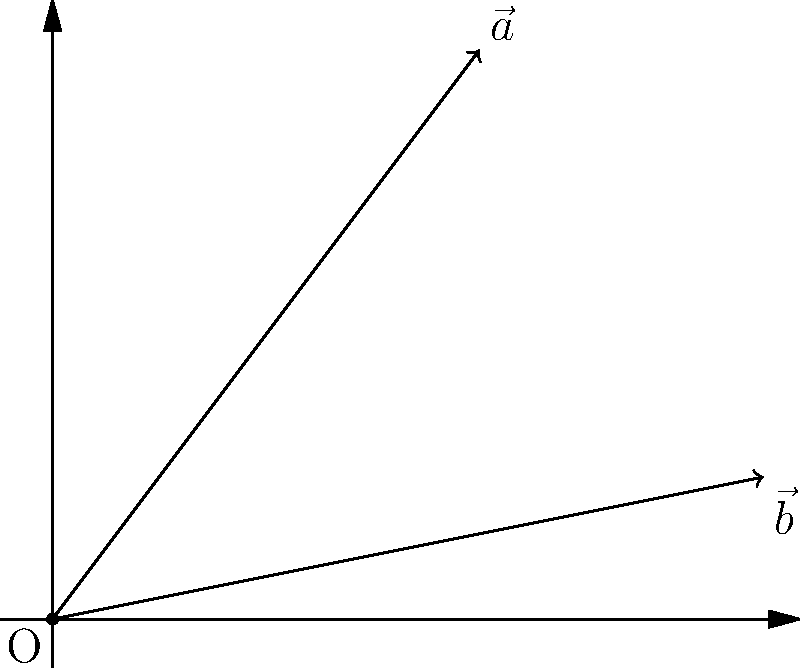Given two vectors $\vec{a}$ and $\vec{b}$ represented in the Cartesian plane as shown in the diagram, determine the angle $\theta$ between them. Express your answer in radians, rounded to two decimal places. To find the angle between two vectors, we can use the dot product formula:

$$\cos \theta = \frac{\vec{a} \cdot \vec{b}}{|\vec{a}||\vec{b}|}$$

Step 1: Determine the coordinates of the vectors
$\vec{a} = (3, 4)$
$\vec{b} = (5, 1)$

Step 2: Calculate the dot product $\vec{a} \cdot \vec{b}$
$\vec{a} \cdot \vec{b} = (3 \times 5) + (4 \times 1) = 15 + 4 = 19$

Step 3: Calculate the magnitudes of the vectors
$|\vec{a}| = \sqrt{3^2 + 4^2} = \sqrt{9 + 16} = \sqrt{25} = 5$
$|\vec{b}| = \sqrt{5^2 + 1^2} = \sqrt{25 + 1} = \sqrt{26}$

Step 4: Apply the dot product formula
$$\cos \theta = \frac{19}{5\sqrt{26}}$$

Step 5: Calculate $\theta$ using the inverse cosine function
$$\theta = \arccos\left(\frac{19}{5\sqrt{26}}\right) \approx 0.52 \text{ radians}$$

Rounding to two decimal places, we get 0.52 radians.
Answer: 0.52 radians 